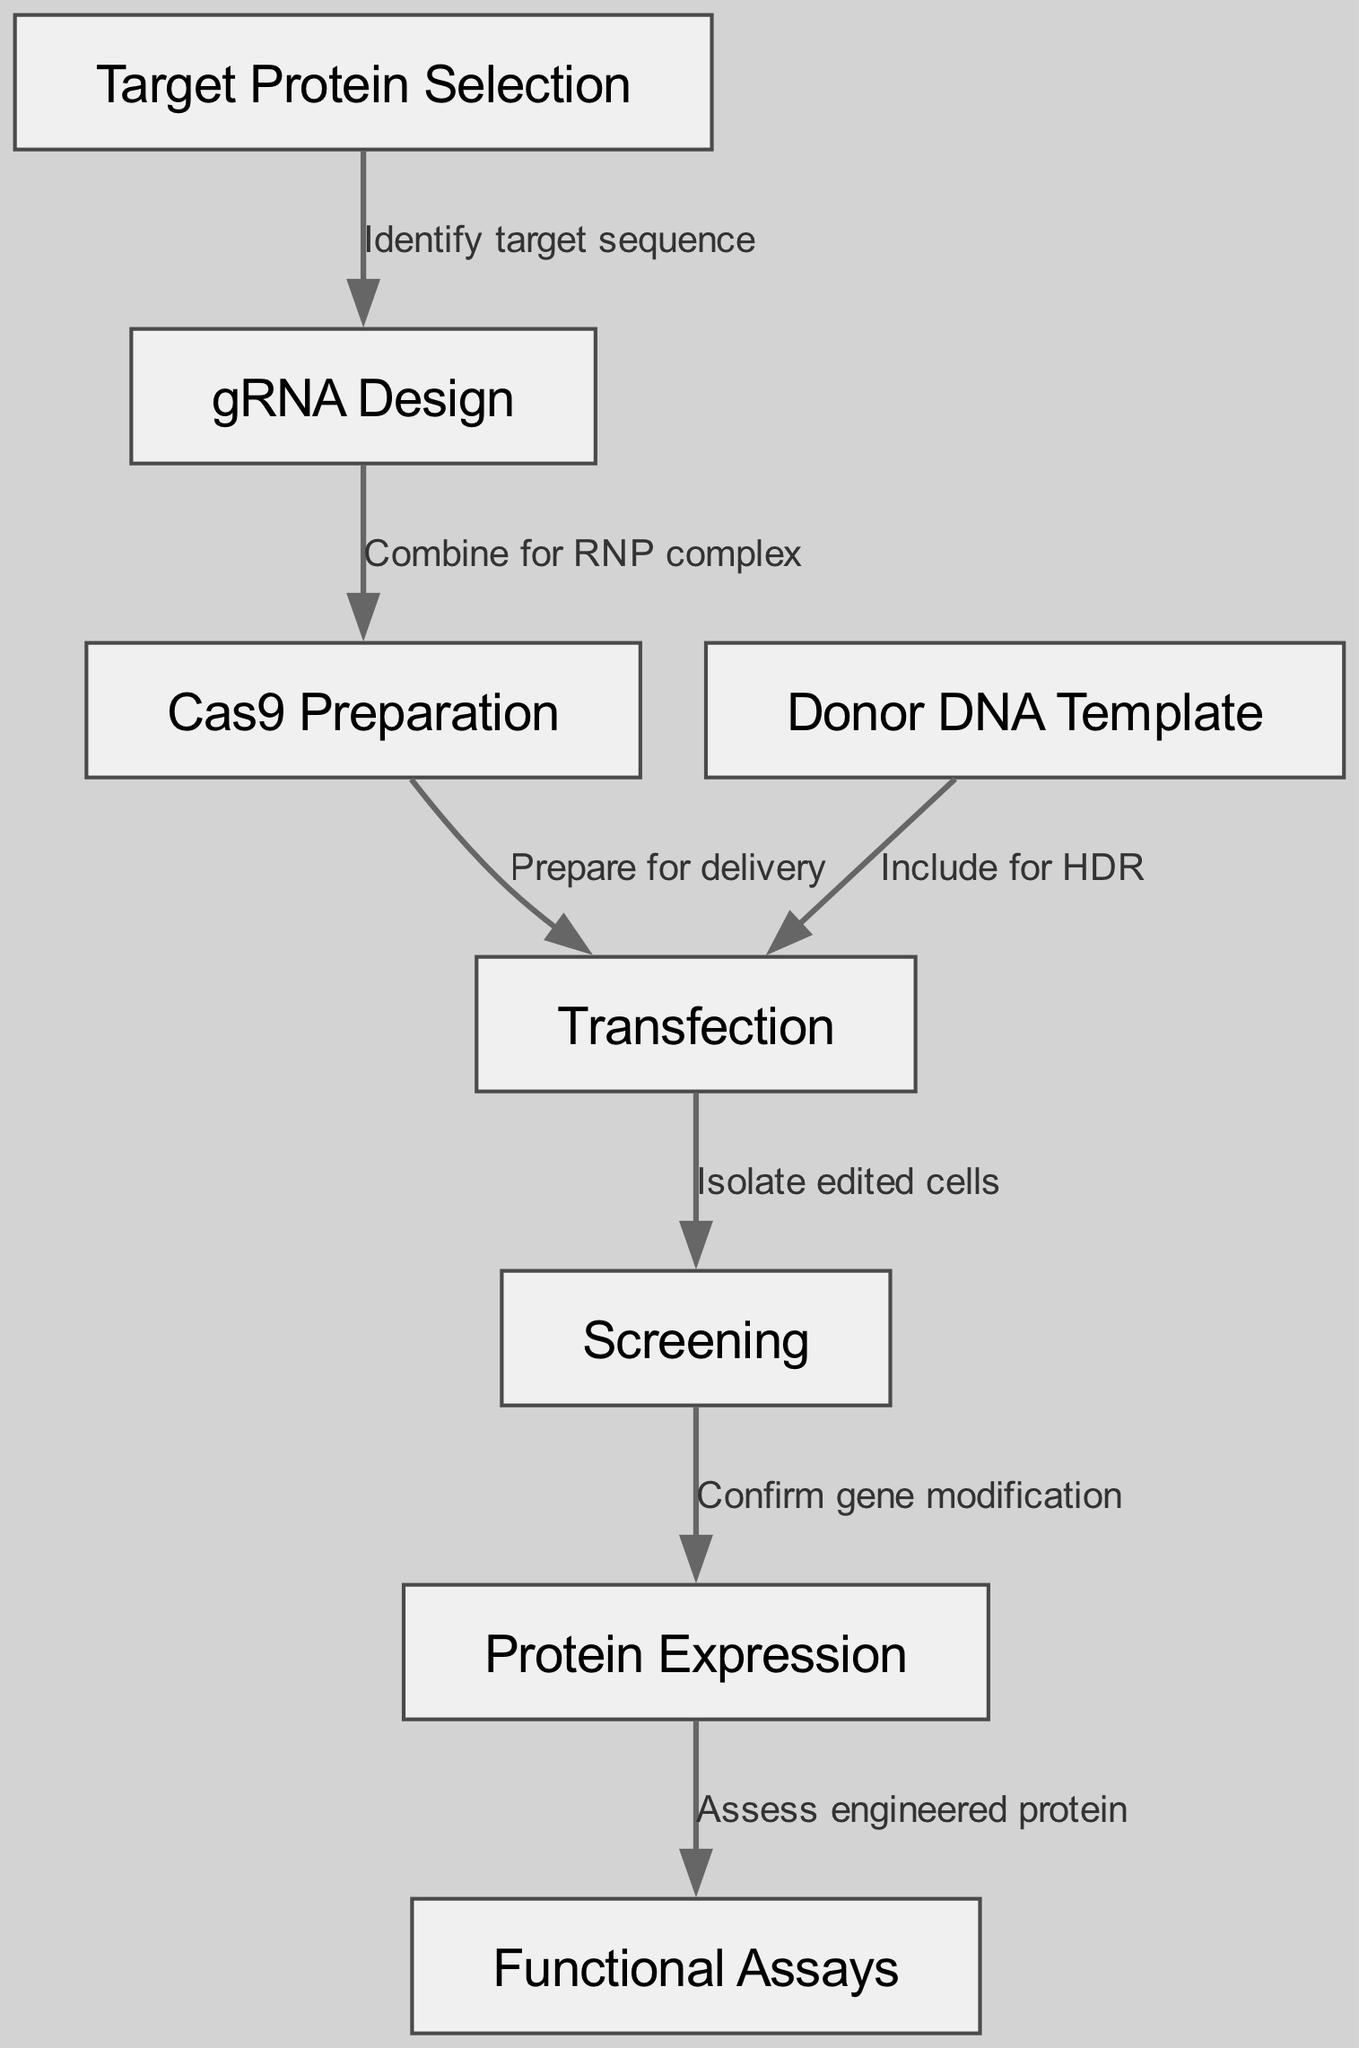What is the first step in the CRISPR gene editing workflow? The first node in the diagram is "Target Protein Selection," which indicates that this is the initial step of the workflow.
Answer: Target Protein Selection How many nodes are present in the diagram? The diagram lists eight nodes, each representing a distinct step or component of the CRISPR gene editing workflow.
Answer: 8 Which node follows gRNA Design? Following the edge labeled "Combine for RNP complex," the node "Cas9 Preparation" is next in the workflow.
Answer: Cas9 Preparation What action is taken after the isolation of edited cells? The next step after "Isolate edited cells" is to "Confirm gene modification," indicating that verification is essential before proceeding.
Answer: Confirm gene modification How many edges are shown in the diagram? By counting the connections between nodes, it is evident that there are six edges representing the sequence of actions in the workflow.
Answer: 6 What is the purpose of the Donor DNA Template in the workflow? The edge labeled "Include for HDR" indicates that the Donor DNA Template is used for homologous directed repair during the editing process.
Answer: Include for HDR What is the final step in this workflow? The last node in the sequence is "Functional Assays," suggesting that the final evaluation of the engineered protein occurs here.
Answer: Functional Assays Which two nodes are directly connected to the Transfection node? The Transfection node is directly connected to "Cas9 Preparation" and "Donor DNA Template," highlighting that both elements are involved in the transfection process.
Answer: Cas9 Preparation, Donor DNA Template How do the nodes relate to each other in terms of sequence? The diagram illustrates a directed flow where each step leads to the next, starting from Target Protein Selection and culminating in Functional Assays, thus forming a cohesive workflow.
Answer: Directed flow from selection to assays 